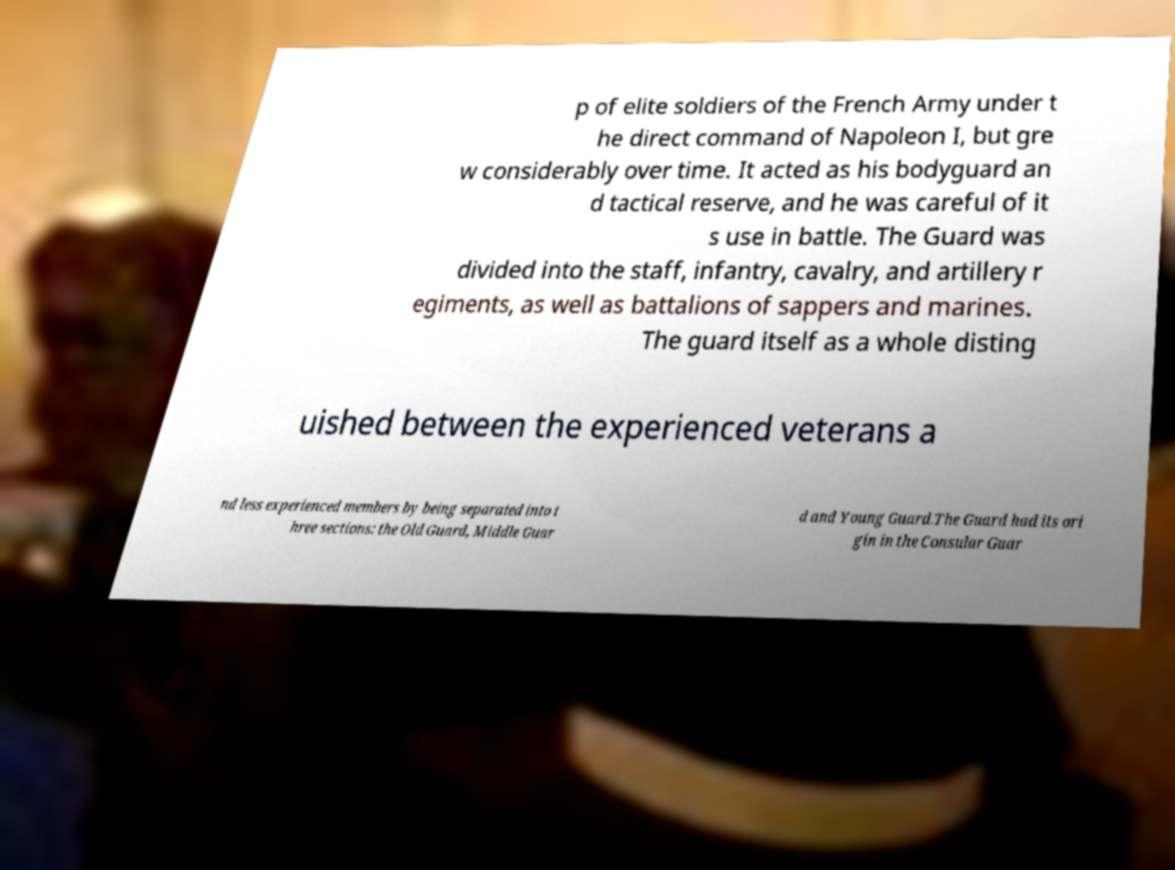Can you read and provide the text displayed in the image?This photo seems to have some interesting text. Can you extract and type it out for me? p of elite soldiers of the French Army under t he direct command of Napoleon I, but gre w considerably over time. It acted as his bodyguard an d tactical reserve, and he was careful of it s use in battle. The Guard was divided into the staff, infantry, cavalry, and artillery r egiments, as well as battalions of sappers and marines. The guard itself as a whole disting uished between the experienced veterans a nd less experienced members by being separated into t hree sections: the Old Guard, Middle Guar d and Young Guard.The Guard had its ori gin in the Consular Guar 